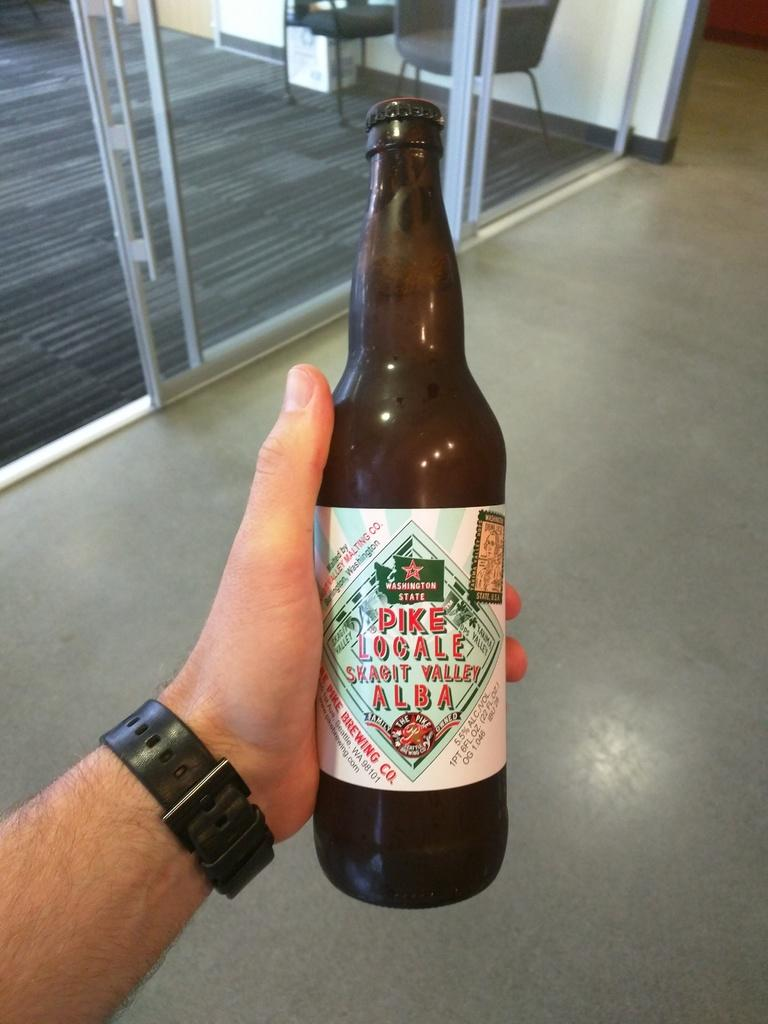Provide a one-sentence caption for the provided image. man with a watch holding a bottle of pike local beer. 